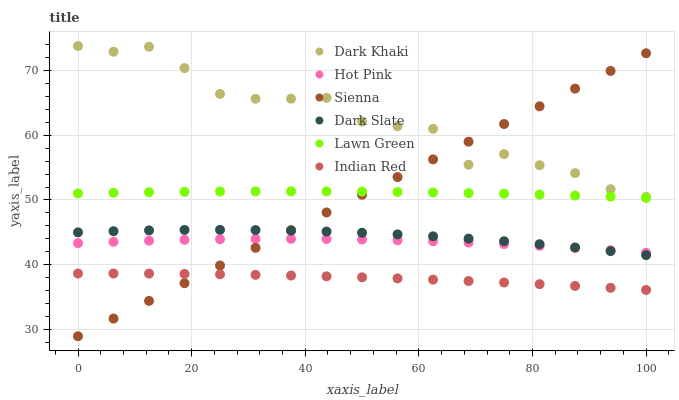Does Indian Red have the minimum area under the curve?
Answer yes or no. Yes. Does Dark Khaki have the maximum area under the curve?
Answer yes or no. Yes. Does Lawn Green have the minimum area under the curve?
Answer yes or no. No. Does Lawn Green have the maximum area under the curve?
Answer yes or no. No. Is Sienna the smoothest?
Answer yes or no. Yes. Is Dark Khaki the roughest?
Answer yes or no. Yes. Is Lawn Green the smoothest?
Answer yes or no. No. Is Lawn Green the roughest?
Answer yes or no. No. Does Sienna have the lowest value?
Answer yes or no. Yes. Does Lawn Green have the lowest value?
Answer yes or no. No. Does Dark Khaki have the highest value?
Answer yes or no. Yes. Does Lawn Green have the highest value?
Answer yes or no. No. Is Hot Pink less than Dark Khaki?
Answer yes or no. Yes. Is Lawn Green greater than Hot Pink?
Answer yes or no. Yes. Does Dark Slate intersect Sienna?
Answer yes or no. Yes. Is Dark Slate less than Sienna?
Answer yes or no. No. Is Dark Slate greater than Sienna?
Answer yes or no. No. Does Hot Pink intersect Dark Khaki?
Answer yes or no. No. 